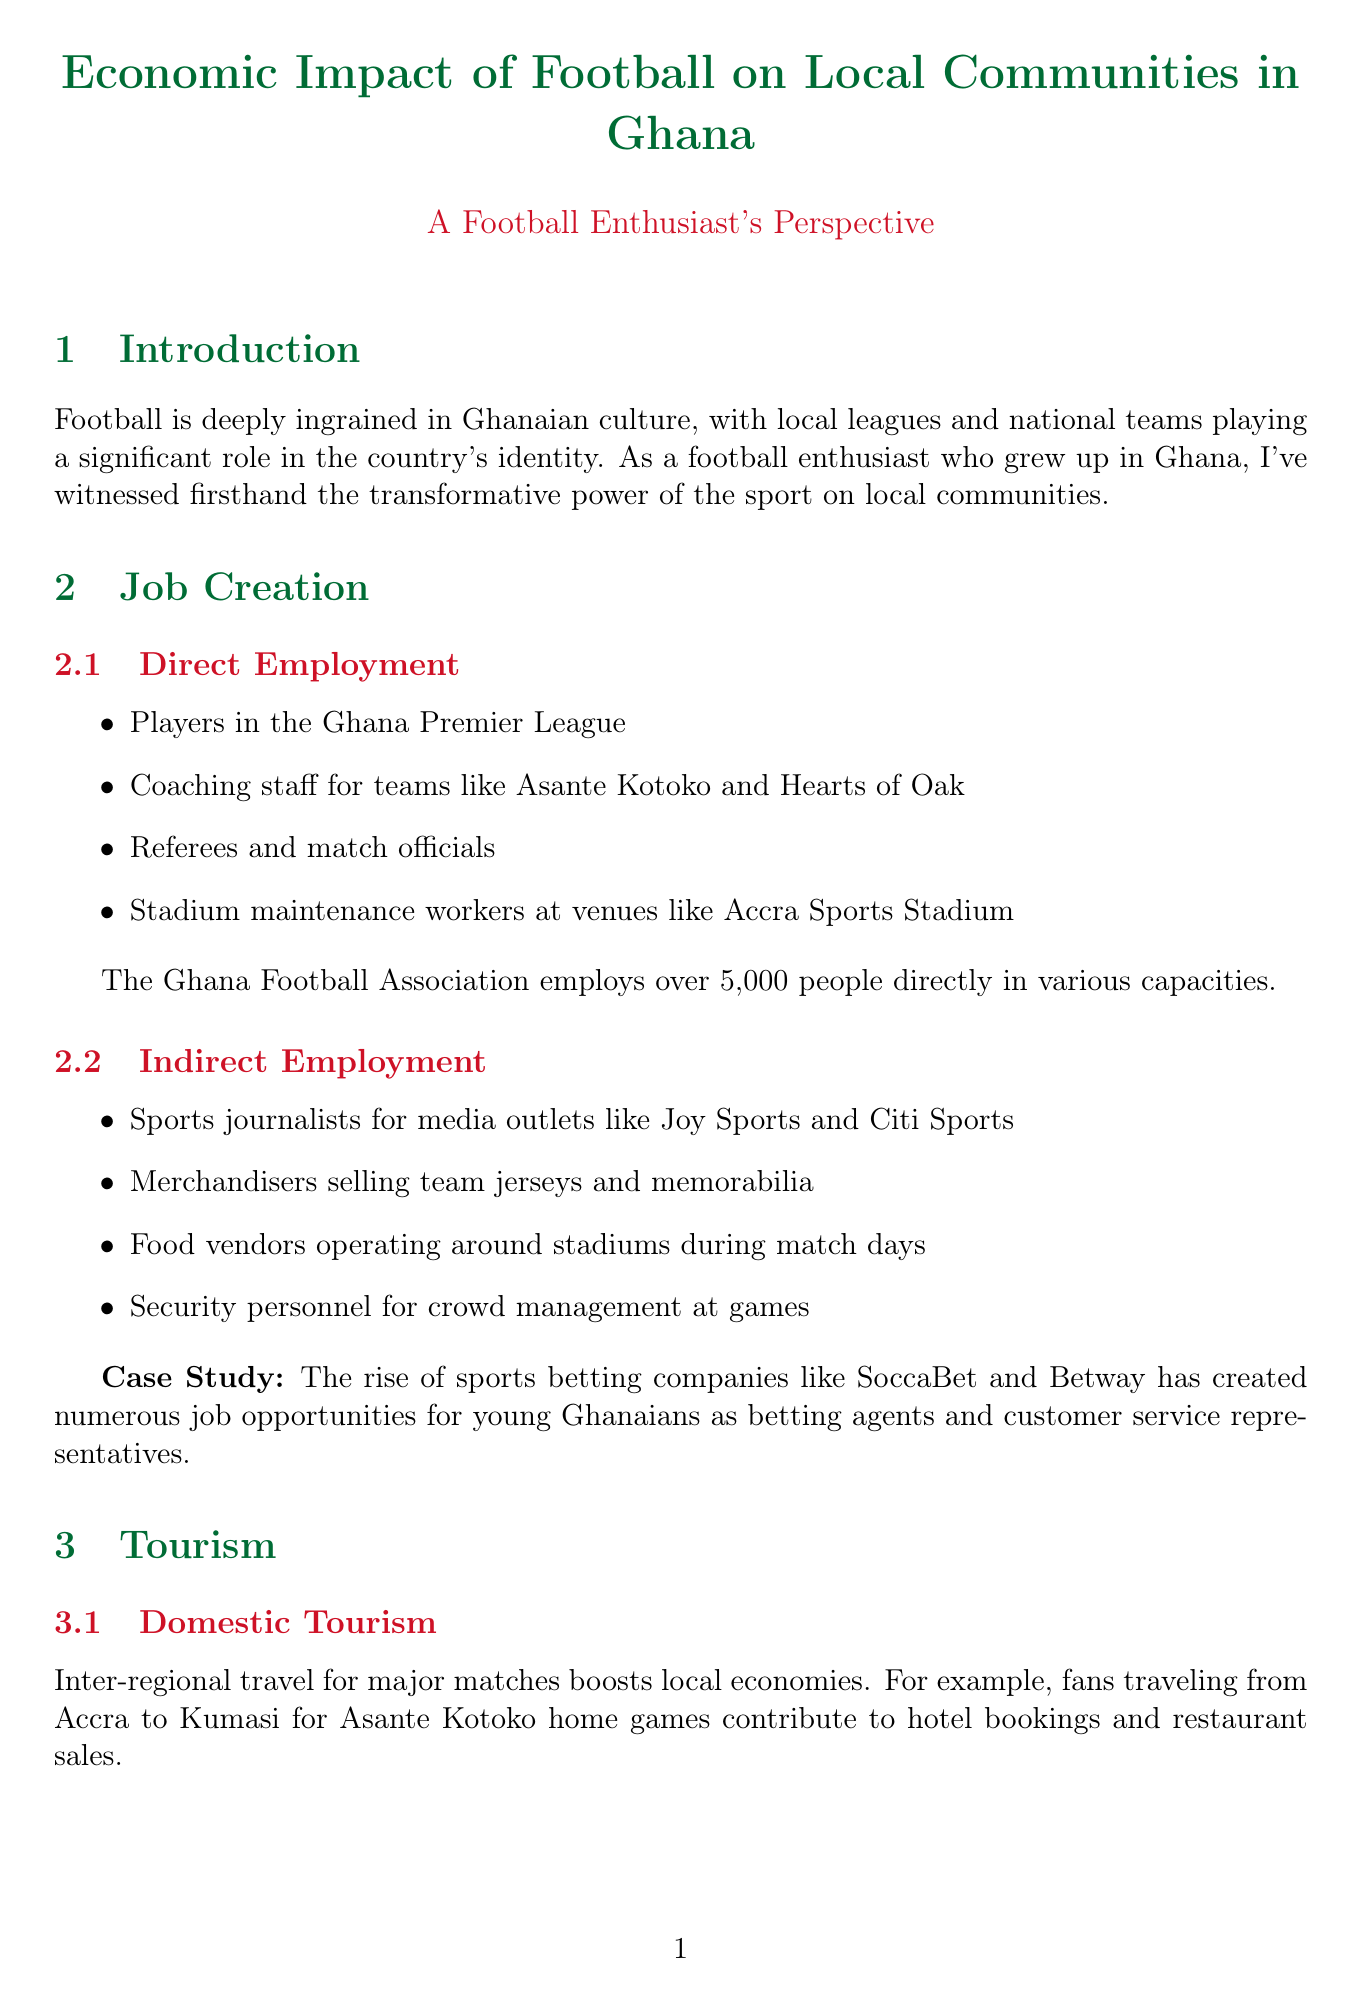What are examples of direct employment in football? The section lists specific roles that entail direct employment in football, including players, coaching staff, referees, and stadium maintenance workers.
Answer: Players, coaching staff, referees, stadium maintenance workers How many people does the Ghana Football Association employ directly? The document specifies that the Ghana Football Association employs over 5,000 people directly in various capacities.
Answer: Over 5,000 people What is the impact of fans traveling for major matches? The document mentions that inter-regional travel for major matches boosts local economies through various contributions such as hotel bookings and restaurant sales.
Answer: Boosts local economies Can you name an event that contributed to international tourism in Ghana? The document lists major events that enhanced international tourism, including the 2008 Africa Cup of Nations and the FIFA U-20 World Cup in 2009.
Answer: 2008 Africa Cup of Nations What type of businesses benefit from match days? This section encompasses businesses that thrive during match days, including mobile food vendors, transportation services, and informal parking operators.
Answer: Mobile food vendors, transportation services, informal parking operators What is one of the social impacts mentioned in the document? The document details that education and football training programs can lead to reduced youth unemployment and crime rates in participating communities.
Answer: Reduced youth unemployment What kind of projects improve community infrastructure? The section describes specific projects that enhance local infrastructure, including stadium renovations and community turf constructions.
Answer: Renovation of Cape Coast Sports Stadium, Astro turfs What is a major challenge facing local leagues in Ghana? The document outlines several challenges, including inconsistent funding for local leagues, among others.
Answer: Inconsistent funding Which recommendation aims to nurture local talent? The document suggests investing in youth academies to help develop and nurture local football talents.
Answer: Invest in youth academies 